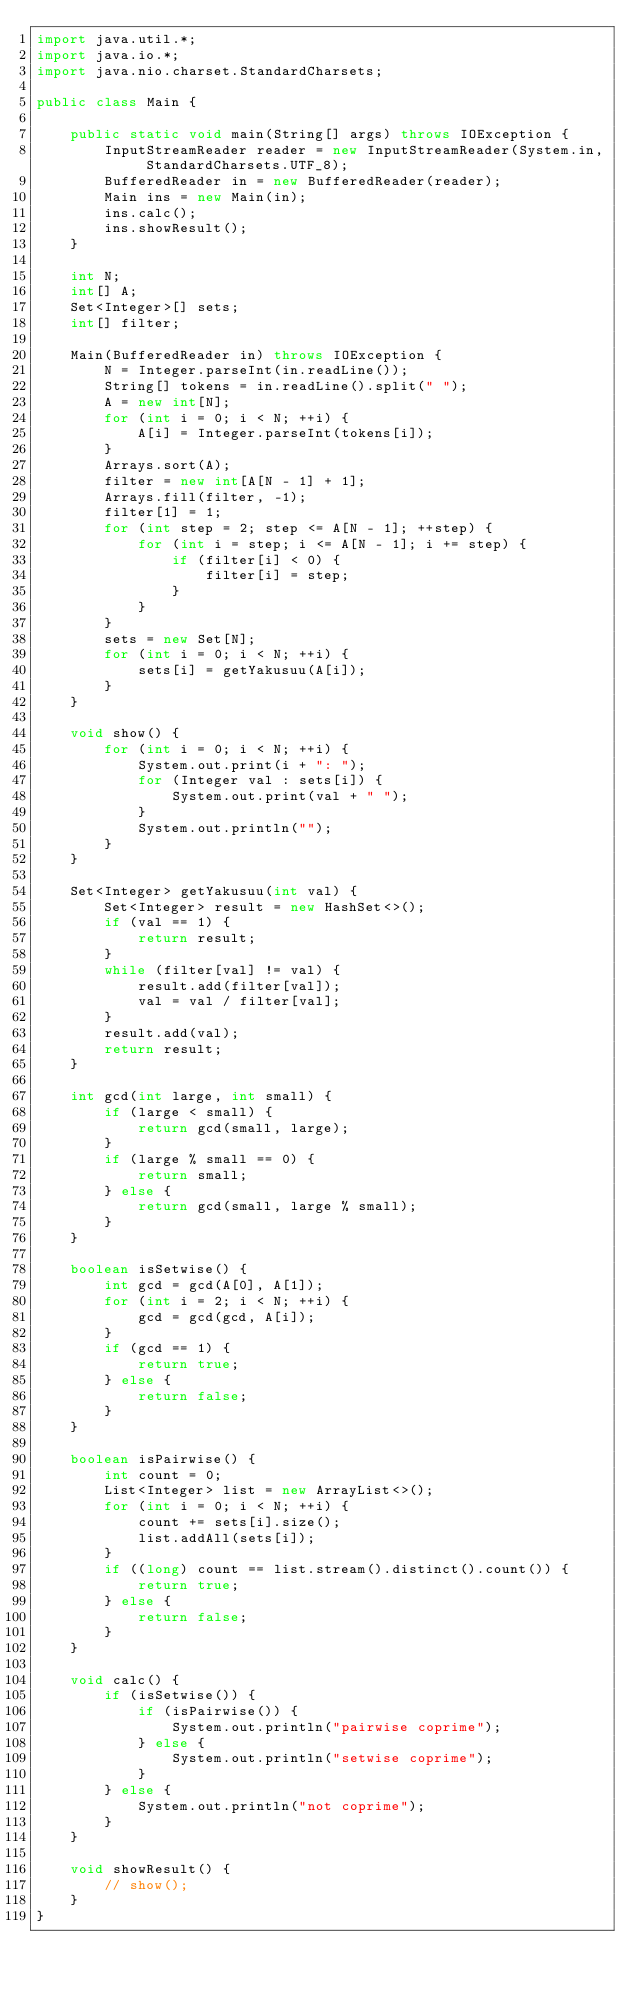<code> <loc_0><loc_0><loc_500><loc_500><_Java_>import java.util.*;
import java.io.*;
import java.nio.charset.StandardCharsets;

public class Main {

	public static void main(String[] args) throws IOException {
		InputStreamReader reader = new InputStreamReader(System.in, StandardCharsets.UTF_8);
		BufferedReader in = new BufferedReader(reader);
		Main ins = new Main(in);
		ins.calc();
		ins.showResult();
	}

	int N;
	int[] A;
	Set<Integer>[] sets;
	int[] filter;

	Main(BufferedReader in) throws IOException {
		N = Integer.parseInt(in.readLine());
		String[] tokens = in.readLine().split(" ");
		A = new int[N];
		for (int i = 0; i < N; ++i) {
			A[i] = Integer.parseInt(tokens[i]);
		}
		Arrays.sort(A);
		filter = new int[A[N - 1] + 1];
		Arrays.fill(filter, -1);
		filter[1] = 1;
		for (int step = 2; step <= A[N - 1]; ++step) {
			for (int i = step; i <= A[N - 1]; i += step) {
				if (filter[i] < 0) {
					filter[i] = step;
				}
			}
		}
		sets = new Set[N];
		for (int i = 0; i < N; ++i) {
			sets[i] = getYakusuu(A[i]);
		}
	}

	void show() {
		for (int i = 0; i < N; ++i) {
			System.out.print(i + ": ");
			for (Integer val : sets[i]) {
				System.out.print(val + " ");
			}
			System.out.println("");
		}
	}

	Set<Integer> getYakusuu(int val) {
		Set<Integer> result = new HashSet<>();
		if (val == 1) {
			return result;
		}
		while (filter[val] != val) {
			result.add(filter[val]);
			val = val / filter[val];
		}
		result.add(val);
		return result;
	}

	int gcd(int large, int small) {
		if (large < small) {
			return gcd(small, large);
		}
		if (large % small == 0) {
			return small;
		} else {
			return gcd(small, large % small);
		}
	}

	boolean isSetwise() {
		int gcd = gcd(A[0], A[1]);
		for (int i = 2; i < N; ++i) {
			gcd = gcd(gcd, A[i]);
		}
		if (gcd == 1) {
			return true;
		} else {
			return false;
		}
	}

	boolean isPairwise() {
		int count = 0;
		List<Integer> list = new ArrayList<>();
		for (int i = 0; i < N; ++i) {
			count += sets[i].size();
			list.addAll(sets[i]);
		}
		if ((long) count == list.stream().distinct().count()) {
			return true;
		} else {
			return false;
		}
	}

	void calc() {
		if (isSetwise()) {
			if (isPairwise()) {
				System.out.println("pairwise coprime");
			} else {
				System.out.println("setwise coprime");
			}
		} else {
			System.out.println("not coprime");
		}
	}

	void showResult() {
		// show();
	}
}</code> 